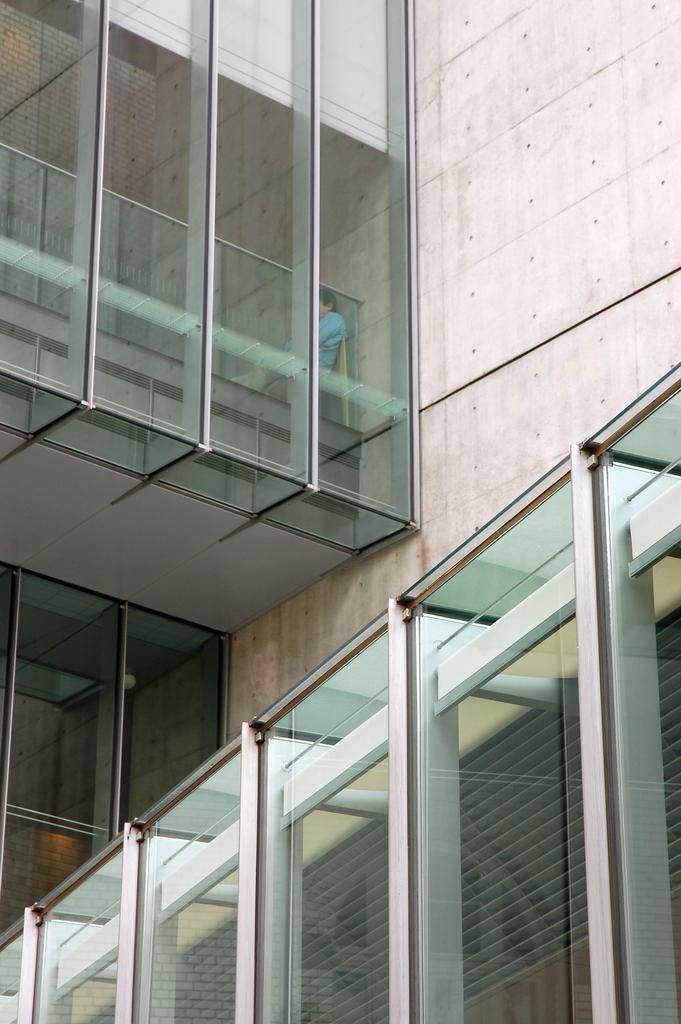Could you give a brief overview of what you see in this image? In this picture we can see a building,wall and a person inside the building. 